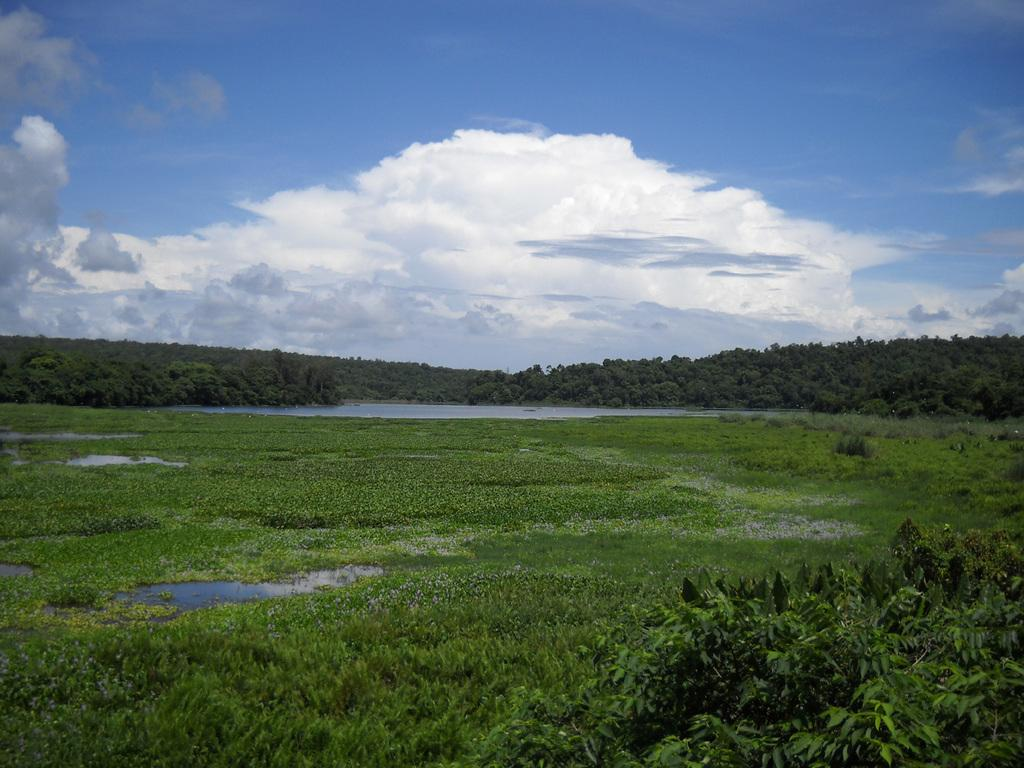What type of vegetation is present in the image? There are plants and grass in the image. Are any plants partially submerged in water? Yes, some plants are seen in the water. What can be seen in the background of the image? There are trees visible in the background. How would you describe the sky in the image? The sky is blue and cloudy. What riddle does the partner in the image pose to the viewer? There is no partner present in the image, and therefore no riddle can be posed. 